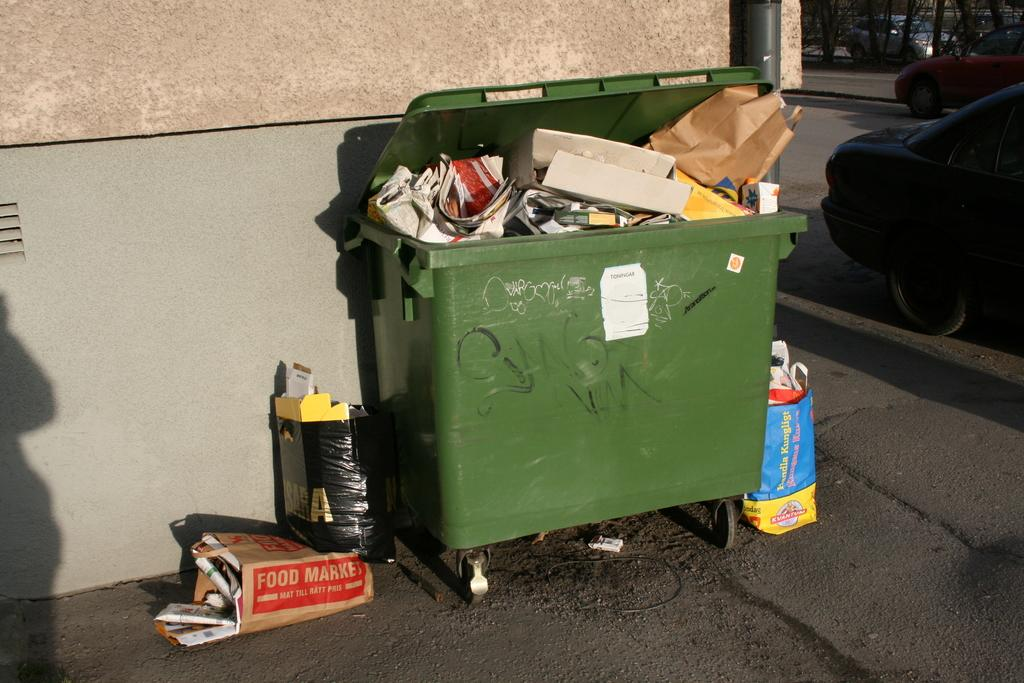<image>
Write a terse but informative summary of the picture. A brown paper bag from the Food Market is laying next to a green dumpster. 